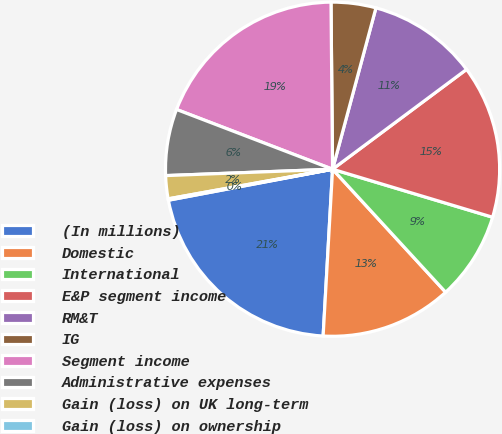Convert chart. <chart><loc_0><loc_0><loc_500><loc_500><pie_chart><fcel>(In millions)<fcel>Domestic<fcel>International<fcel>E&P segment income<fcel>RM&T<fcel>IG<fcel>Segment income<fcel>Administrative expenses<fcel>Gain (loss) on UK long-term<fcel>Gain (loss) on ownership<nl><fcel>21.13%<fcel>12.73%<fcel>8.53%<fcel>14.83%<fcel>10.63%<fcel>4.33%<fcel>19.03%<fcel>6.43%<fcel>2.23%<fcel>0.13%<nl></chart> 